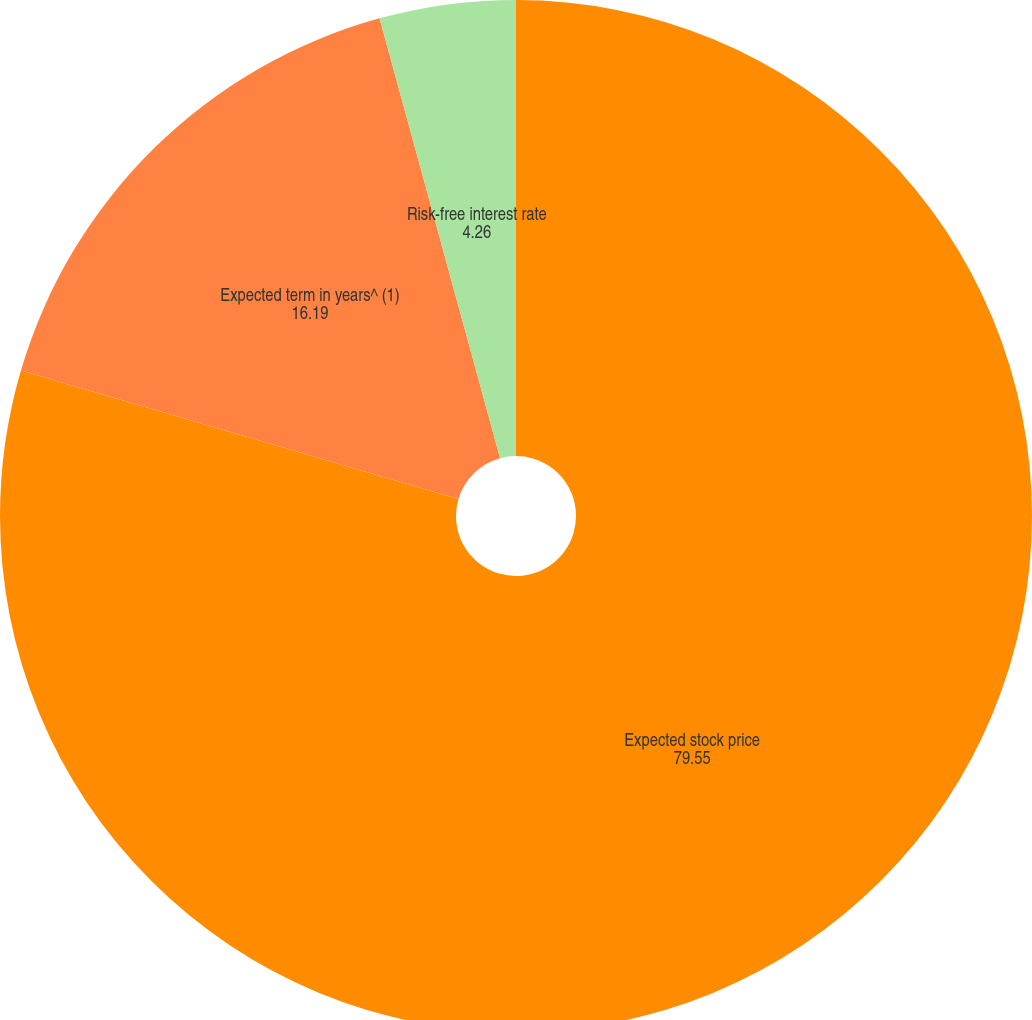Convert chart. <chart><loc_0><loc_0><loc_500><loc_500><pie_chart><fcel>Expected stock price<fcel>Expected term in years^ (1)<fcel>Risk-free interest rate<nl><fcel>79.55%<fcel>16.19%<fcel>4.26%<nl></chart> 